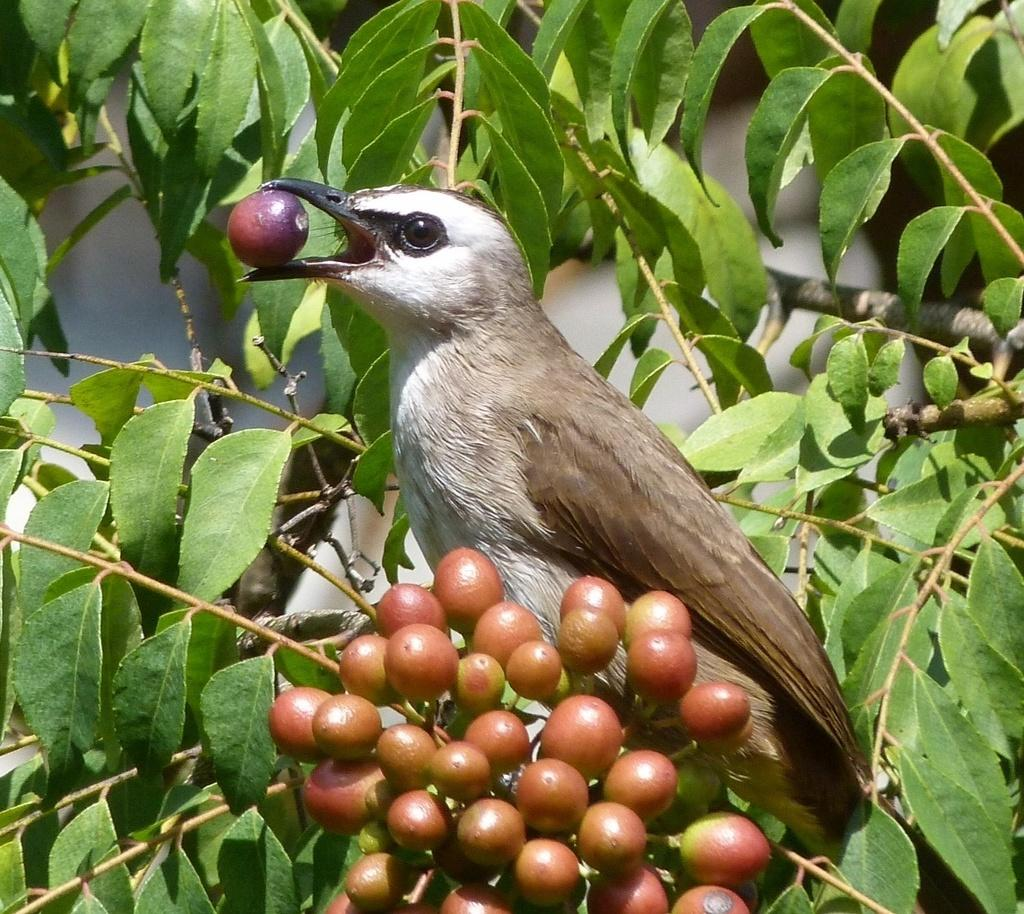What type of animal can be seen in the image? There is a bird in the image. Where is the bird located in the image? The bird is sitting on a tree branch. What is the tree branch holding? The tree branch has fruits. What is the bird doing with the fruit? The bird is holding a fruit in its mouth. What type of riddle can be solved by the bird in the image? There is no riddle present in the image, nor is the bird solving any riddle. 